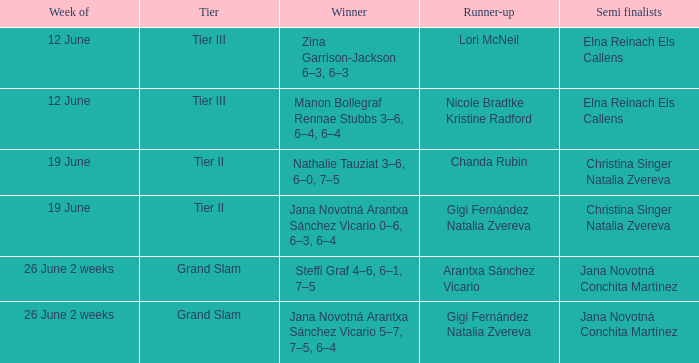Who is the winner in the week listed as 26 June 2 weeks, when the runner-up is Arantxa Sánchez Vicario? Steffi Graf 4–6, 6–1, 7–5. 